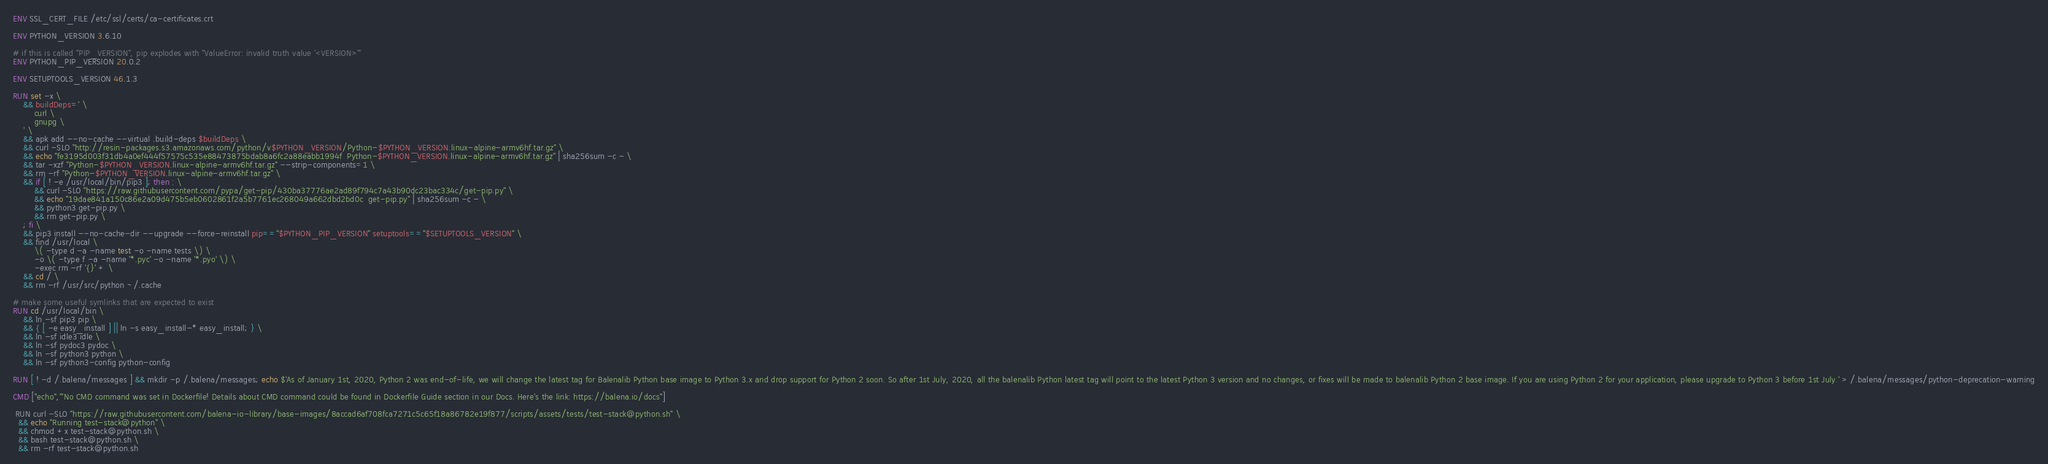Convert code to text. <code><loc_0><loc_0><loc_500><loc_500><_Dockerfile_>ENV SSL_CERT_FILE /etc/ssl/certs/ca-certificates.crt

ENV PYTHON_VERSION 3.6.10

# if this is called "PIP_VERSION", pip explodes with "ValueError: invalid truth value '<VERSION>'"
ENV PYTHON_PIP_VERSION 20.0.2

ENV SETUPTOOLS_VERSION 46.1.3

RUN set -x \
	&& buildDeps=' \
		curl \
		gnupg \
	' \
	&& apk add --no-cache --virtual .build-deps $buildDeps \
	&& curl -SLO "http://resin-packages.s3.amazonaws.com/python/v$PYTHON_VERSION/Python-$PYTHON_VERSION.linux-alpine-armv6hf.tar.gz" \
	&& echo "fe3195d003f31db4a0ef444f57575c535e88473875bdab8a6fc2a88eabb1994f  Python-$PYTHON_VERSION.linux-alpine-armv6hf.tar.gz" | sha256sum -c - \
	&& tar -xzf "Python-$PYTHON_VERSION.linux-alpine-armv6hf.tar.gz" --strip-components=1 \
	&& rm -rf "Python-$PYTHON_VERSION.linux-alpine-armv6hf.tar.gz" \
	&& if [ ! -e /usr/local/bin/pip3 ]; then : \
		&& curl -SLO "https://raw.githubusercontent.com/pypa/get-pip/430ba37776ae2ad89f794c7a43b90dc23bac334c/get-pip.py" \
		&& echo "19dae841a150c86e2a09d475b5eb0602861f2a5b7761ec268049a662dbd2bd0c  get-pip.py" | sha256sum -c - \
		&& python3 get-pip.py \
		&& rm get-pip.py \
	; fi \
	&& pip3 install --no-cache-dir --upgrade --force-reinstall pip=="$PYTHON_PIP_VERSION" setuptools=="$SETUPTOOLS_VERSION" \
	&& find /usr/local \
		\( -type d -a -name test -o -name tests \) \
		-o \( -type f -a -name '*.pyc' -o -name '*.pyo' \) \
		-exec rm -rf '{}' + \
	&& cd / \
	&& rm -rf /usr/src/python ~/.cache

# make some useful symlinks that are expected to exist
RUN cd /usr/local/bin \
	&& ln -sf pip3 pip \
	&& { [ -e easy_install ] || ln -s easy_install-* easy_install; } \
	&& ln -sf idle3 idle \
	&& ln -sf pydoc3 pydoc \
	&& ln -sf python3 python \
	&& ln -sf python3-config python-config

RUN [ ! -d /.balena/messages ] && mkdir -p /.balena/messages; echo $'As of January 1st, 2020, Python 2 was end-of-life, we will change the latest tag for Balenalib Python base image to Python 3.x and drop support for Python 2 soon. So after 1st July, 2020, all the balenalib Python latest tag will point to the latest Python 3 version and no changes, or fixes will be made to balenalib Python 2 base image. If you are using Python 2 for your application, please upgrade to Python 3 before 1st July.' > /.balena/messages/python-deprecation-warning

CMD ["echo","'No CMD command was set in Dockerfile! Details about CMD command could be found in Dockerfile Guide section in our Docs. Here's the link: https://balena.io/docs"]

 RUN curl -SLO "https://raw.githubusercontent.com/balena-io-library/base-images/8accad6af708fca7271c5c65f18a86782e19f877/scripts/assets/tests/test-stack@python.sh" \
  && echo "Running test-stack@python" \
  && chmod +x test-stack@python.sh \
  && bash test-stack@python.sh \
  && rm -rf test-stack@python.sh 
</code> 